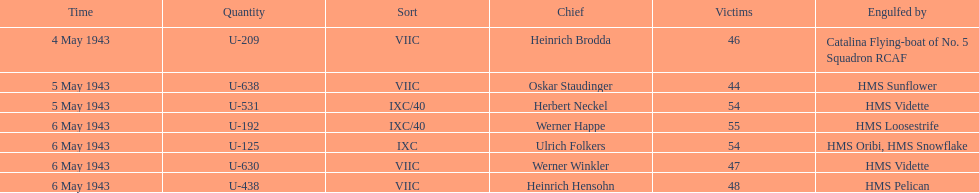What is the only vessel to sink multiple u-boats? HMS Vidette. 